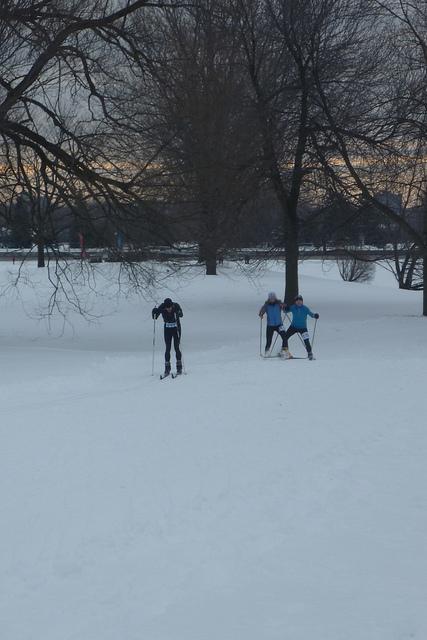How many people are there?
Give a very brief answer. 3. 